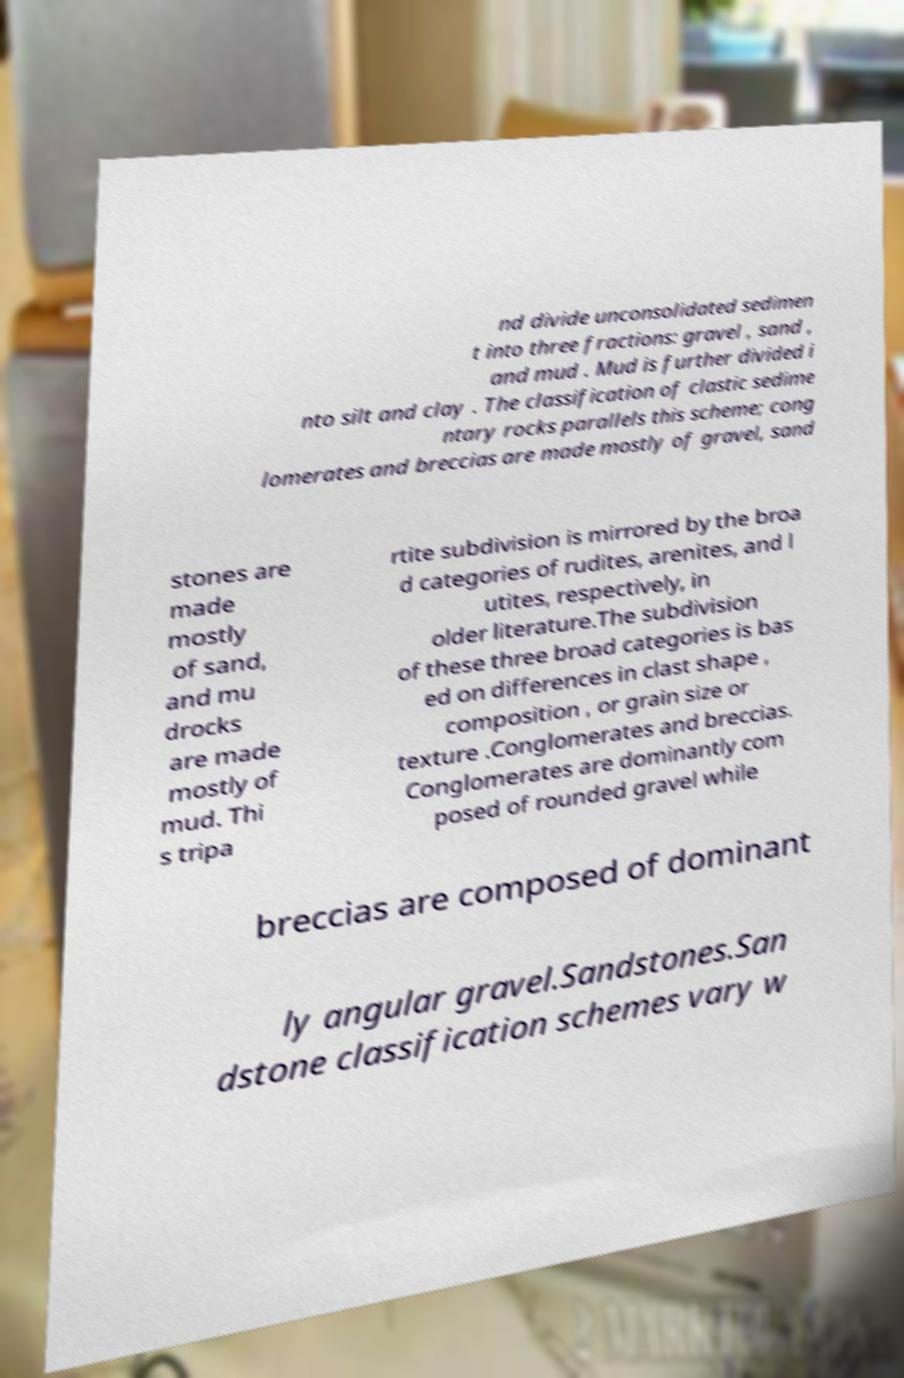What messages or text are displayed in this image? I need them in a readable, typed format. nd divide unconsolidated sedimen t into three fractions: gravel , sand , and mud . Mud is further divided i nto silt and clay . The classification of clastic sedime ntary rocks parallels this scheme; cong lomerates and breccias are made mostly of gravel, sand stones are made mostly of sand, and mu drocks are made mostly of mud. Thi s tripa rtite subdivision is mirrored by the broa d categories of rudites, arenites, and l utites, respectively, in older literature.The subdivision of these three broad categories is bas ed on differences in clast shape , composition , or grain size or texture .Conglomerates and breccias. Conglomerates are dominantly com posed of rounded gravel while breccias are composed of dominant ly angular gravel.Sandstones.San dstone classification schemes vary w 